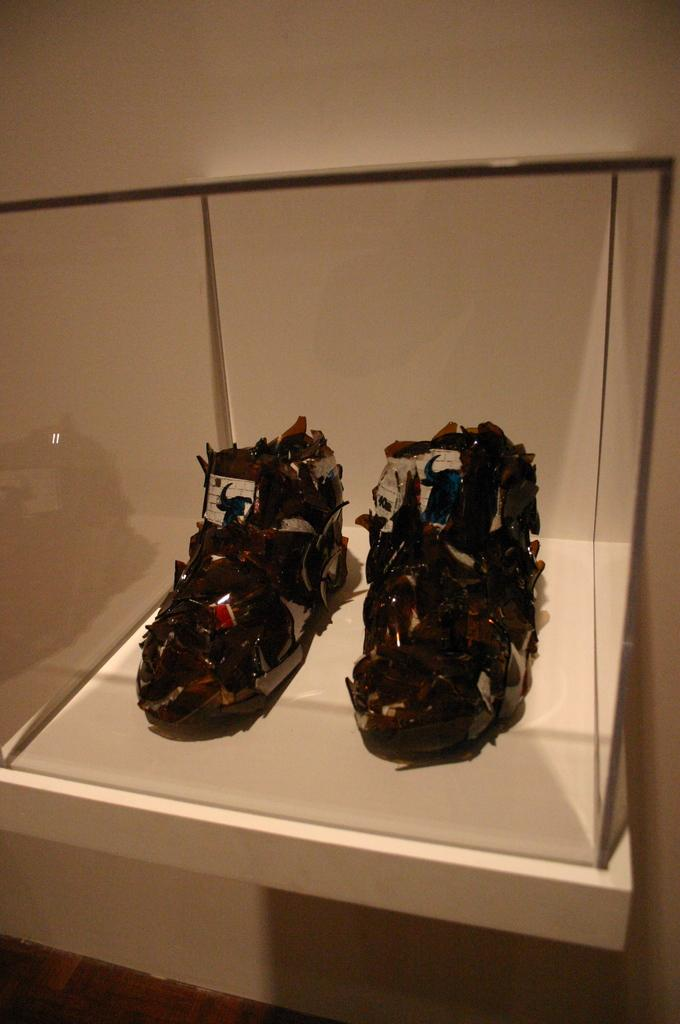What type of objects are inside the glass box in the image? There are shoe-like structured objects in a glass box. Where is the glass box located in the image? The glass box is on a table. What can be observed on the surface of the objects in the glass box? There are glass pieces on the objects. What is visible behind the glass box in the image? There is a wall behind the glass box. What type of soup is being served on the island in the image? There is no soup or island present in the image; it features a glass box with shoe-like structured objects on a table in front of a wall. 